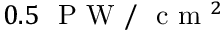Convert formula to latex. <formula><loc_0><loc_0><loc_500><loc_500>0 . 5 P W / c m ^ { 2 }</formula> 